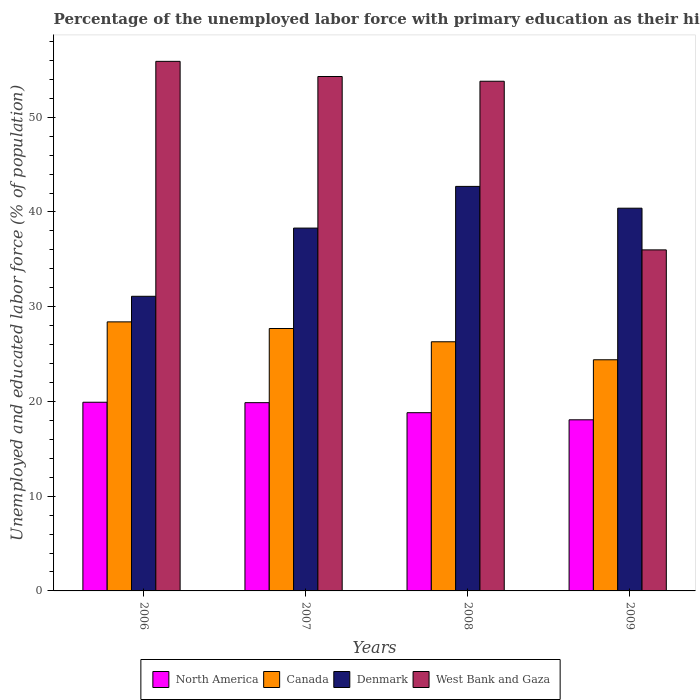In how many cases, is the number of bars for a given year not equal to the number of legend labels?
Your response must be concise. 0. What is the percentage of the unemployed labor force with primary education in North America in 2009?
Your answer should be very brief. 18.06. Across all years, what is the maximum percentage of the unemployed labor force with primary education in Denmark?
Ensure brevity in your answer.  42.7. Across all years, what is the minimum percentage of the unemployed labor force with primary education in Denmark?
Ensure brevity in your answer.  31.1. What is the total percentage of the unemployed labor force with primary education in Canada in the graph?
Give a very brief answer. 106.8. What is the difference between the percentage of the unemployed labor force with primary education in Canada in 2007 and that in 2009?
Make the answer very short. 3.3. What is the difference between the percentage of the unemployed labor force with primary education in West Bank and Gaza in 2008 and the percentage of the unemployed labor force with primary education in Canada in 2007?
Give a very brief answer. 26.1. What is the average percentage of the unemployed labor force with primary education in West Bank and Gaza per year?
Your response must be concise. 50. In the year 2009, what is the difference between the percentage of the unemployed labor force with primary education in West Bank and Gaza and percentage of the unemployed labor force with primary education in North America?
Give a very brief answer. 17.94. What is the ratio of the percentage of the unemployed labor force with primary education in Denmark in 2006 to that in 2007?
Offer a very short reply. 0.81. Is the percentage of the unemployed labor force with primary education in West Bank and Gaza in 2006 less than that in 2007?
Make the answer very short. No. What is the difference between the highest and the second highest percentage of the unemployed labor force with primary education in Canada?
Your response must be concise. 0.7. What is the difference between the highest and the lowest percentage of the unemployed labor force with primary education in North America?
Offer a terse response. 1.85. Is it the case that in every year, the sum of the percentage of the unemployed labor force with primary education in Denmark and percentage of the unemployed labor force with primary education in Canada is greater than the sum of percentage of the unemployed labor force with primary education in North America and percentage of the unemployed labor force with primary education in West Bank and Gaza?
Provide a short and direct response. Yes. What does the 3rd bar from the left in 2007 represents?
Your answer should be compact. Denmark. How many bars are there?
Offer a terse response. 16. Where does the legend appear in the graph?
Provide a succinct answer. Bottom center. How many legend labels are there?
Give a very brief answer. 4. How are the legend labels stacked?
Provide a succinct answer. Horizontal. What is the title of the graph?
Give a very brief answer. Percentage of the unemployed labor force with primary education as their highest grade. What is the label or title of the Y-axis?
Your response must be concise. Unemployed and educated labor force (% of population). What is the Unemployed and educated labor force (% of population) in North America in 2006?
Your response must be concise. 19.92. What is the Unemployed and educated labor force (% of population) in Canada in 2006?
Your answer should be very brief. 28.4. What is the Unemployed and educated labor force (% of population) of Denmark in 2006?
Make the answer very short. 31.1. What is the Unemployed and educated labor force (% of population) of West Bank and Gaza in 2006?
Provide a succinct answer. 55.9. What is the Unemployed and educated labor force (% of population) in North America in 2007?
Your response must be concise. 19.87. What is the Unemployed and educated labor force (% of population) of Canada in 2007?
Offer a terse response. 27.7. What is the Unemployed and educated labor force (% of population) in Denmark in 2007?
Your response must be concise. 38.3. What is the Unemployed and educated labor force (% of population) in West Bank and Gaza in 2007?
Keep it short and to the point. 54.3. What is the Unemployed and educated labor force (% of population) of North America in 2008?
Your answer should be very brief. 18.81. What is the Unemployed and educated labor force (% of population) in Canada in 2008?
Ensure brevity in your answer.  26.3. What is the Unemployed and educated labor force (% of population) in Denmark in 2008?
Make the answer very short. 42.7. What is the Unemployed and educated labor force (% of population) of West Bank and Gaza in 2008?
Your response must be concise. 53.8. What is the Unemployed and educated labor force (% of population) of North America in 2009?
Your answer should be compact. 18.06. What is the Unemployed and educated labor force (% of population) of Canada in 2009?
Your answer should be very brief. 24.4. What is the Unemployed and educated labor force (% of population) in Denmark in 2009?
Your answer should be very brief. 40.4. What is the Unemployed and educated labor force (% of population) of West Bank and Gaza in 2009?
Keep it short and to the point. 36. Across all years, what is the maximum Unemployed and educated labor force (% of population) in North America?
Keep it short and to the point. 19.92. Across all years, what is the maximum Unemployed and educated labor force (% of population) of Canada?
Provide a succinct answer. 28.4. Across all years, what is the maximum Unemployed and educated labor force (% of population) of Denmark?
Your answer should be very brief. 42.7. Across all years, what is the maximum Unemployed and educated labor force (% of population) of West Bank and Gaza?
Keep it short and to the point. 55.9. Across all years, what is the minimum Unemployed and educated labor force (% of population) of North America?
Provide a short and direct response. 18.06. Across all years, what is the minimum Unemployed and educated labor force (% of population) in Canada?
Keep it short and to the point. 24.4. Across all years, what is the minimum Unemployed and educated labor force (% of population) in Denmark?
Offer a terse response. 31.1. Across all years, what is the minimum Unemployed and educated labor force (% of population) in West Bank and Gaza?
Offer a very short reply. 36. What is the total Unemployed and educated labor force (% of population) of North America in the graph?
Offer a terse response. 76.66. What is the total Unemployed and educated labor force (% of population) of Canada in the graph?
Ensure brevity in your answer.  106.8. What is the total Unemployed and educated labor force (% of population) of Denmark in the graph?
Ensure brevity in your answer.  152.5. What is the total Unemployed and educated labor force (% of population) of West Bank and Gaza in the graph?
Keep it short and to the point. 200. What is the difference between the Unemployed and educated labor force (% of population) of North America in 2006 and that in 2007?
Provide a succinct answer. 0.05. What is the difference between the Unemployed and educated labor force (% of population) in Denmark in 2006 and that in 2007?
Ensure brevity in your answer.  -7.2. What is the difference between the Unemployed and educated labor force (% of population) in West Bank and Gaza in 2006 and that in 2007?
Provide a short and direct response. 1.6. What is the difference between the Unemployed and educated labor force (% of population) in North America in 2006 and that in 2008?
Provide a short and direct response. 1.1. What is the difference between the Unemployed and educated labor force (% of population) of Denmark in 2006 and that in 2008?
Give a very brief answer. -11.6. What is the difference between the Unemployed and educated labor force (% of population) of West Bank and Gaza in 2006 and that in 2008?
Your answer should be very brief. 2.1. What is the difference between the Unemployed and educated labor force (% of population) of North America in 2006 and that in 2009?
Your answer should be very brief. 1.85. What is the difference between the Unemployed and educated labor force (% of population) of Denmark in 2006 and that in 2009?
Offer a terse response. -9.3. What is the difference between the Unemployed and educated labor force (% of population) of North America in 2007 and that in 2008?
Provide a short and direct response. 1.06. What is the difference between the Unemployed and educated labor force (% of population) of Denmark in 2007 and that in 2008?
Your answer should be very brief. -4.4. What is the difference between the Unemployed and educated labor force (% of population) in West Bank and Gaza in 2007 and that in 2008?
Provide a succinct answer. 0.5. What is the difference between the Unemployed and educated labor force (% of population) in North America in 2007 and that in 2009?
Your answer should be compact. 1.81. What is the difference between the Unemployed and educated labor force (% of population) of West Bank and Gaza in 2007 and that in 2009?
Your response must be concise. 18.3. What is the difference between the Unemployed and educated labor force (% of population) in North America in 2008 and that in 2009?
Offer a terse response. 0.75. What is the difference between the Unemployed and educated labor force (% of population) of Denmark in 2008 and that in 2009?
Provide a succinct answer. 2.3. What is the difference between the Unemployed and educated labor force (% of population) of West Bank and Gaza in 2008 and that in 2009?
Your answer should be very brief. 17.8. What is the difference between the Unemployed and educated labor force (% of population) in North America in 2006 and the Unemployed and educated labor force (% of population) in Canada in 2007?
Ensure brevity in your answer.  -7.78. What is the difference between the Unemployed and educated labor force (% of population) of North America in 2006 and the Unemployed and educated labor force (% of population) of Denmark in 2007?
Offer a terse response. -18.38. What is the difference between the Unemployed and educated labor force (% of population) of North America in 2006 and the Unemployed and educated labor force (% of population) of West Bank and Gaza in 2007?
Your response must be concise. -34.38. What is the difference between the Unemployed and educated labor force (% of population) in Canada in 2006 and the Unemployed and educated labor force (% of population) in West Bank and Gaza in 2007?
Keep it short and to the point. -25.9. What is the difference between the Unemployed and educated labor force (% of population) in Denmark in 2006 and the Unemployed and educated labor force (% of population) in West Bank and Gaza in 2007?
Keep it short and to the point. -23.2. What is the difference between the Unemployed and educated labor force (% of population) in North America in 2006 and the Unemployed and educated labor force (% of population) in Canada in 2008?
Offer a very short reply. -6.38. What is the difference between the Unemployed and educated labor force (% of population) in North America in 2006 and the Unemployed and educated labor force (% of population) in Denmark in 2008?
Offer a very short reply. -22.78. What is the difference between the Unemployed and educated labor force (% of population) of North America in 2006 and the Unemployed and educated labor force (% of population) of West Bank and Gaza in 2008?
Provide a succinct answer. -33.88. What is the difference between the Unemployed and educated labor force (% of population) of Canada in 2006 and the Unemployed and educated labor force (% of population) of Denmark in 2008?
Make the answer very short. -14.3. What is the difference between the Unemployed and educated labor force (% of population) in Canada in 2006 and the Unemployed and educated labor force (% of population) in West Bank and Gaza in 2008?
Give a very brief answer. -25.4. What is the difference between the Unemployed and educated labor force (% of population) in Denmark in 2006 and the Unemployed and educated labor force (% of population) in West Bank and Gaza in 2008?
Offer a very short reply. -22.7. What is the difference between the Unemployed and educated labor force (% of population) in North America in 2006 and the Unemployed and educated labor force (% of population) in Canada in 2009?
Provide a short and direct response. -4.48. What is the difference between the Unemployed and educated labor force (% of population) of North America in 2006 and the Unemployed and educated labor force (% of population) of Denmark in 2009?
Ensure brevity in your answer.  -20.48. What is the difference between the Unemployed and educated labor force (% of population) of North America in 2006 and the Unemployed and educated labor force (% of population) of West Bank and Gaza in 2009?
Give a very brief answer. -16.08. What is the difference between the Unemployed and educated labor force (% of population) of Canada in 2006 and the Unemployed and educated labor force (% of population) of Denmark in 2009?
Ensure brevity in your answer.  -12. What is the difference between the Unemployed and educated labor force (% of population) in North America in 2007 and the Unemployed and educated labor force (% of population) in Canada in 2008?
Give a very brief answer. -6.43. What is the difference between the Unemployed and educated labor force (% of population) of North America in 2007 and the Unemployed and educated labor force (% of population) of Denmark in 2008?
Make the answer very short. -22.83. What is the difference between the Unemployed and educated labor force (% of population) of North America in 2007 and the Unemployed and educated labor force (% of population) of West Bank and Gaza in 2008?
Your answer should be very brief. -33.93. What is the difference between the Unemployed and educated labor force (% of population) of Canada in 2007 and the Unemployed and educated labor force (% of population) of Denmark in 2008?
Make the answer very short. -15. What is the difference between the Unemployed and educated labor force (% of population) in Canada in 2007 and the Unemployed and educated labor force (% of population) in West Bank and Gaza in 2008?
Give a very brief answer. -26.1. What is the difference between the Unemployed and educated labor force (% of population) in Denmark in 2007 and the Unemployed and educated labor force (% of population) in West Bank and Gaza in 2008?
Your response must be concise. -15.5. What is the difference between the Unemployed and educated labor force (% of population) in North America in 2007 and the Unemployed and educated labor force (% of population) in Canada in 2009?
Offer a terse response. -4.53. What is the difference between the Unemployed and educated labor force (% of population) in North America in 2007 and the Unemployed and educated labor force (% of population) in Denmark in 2009?
Offer a terse response. -20.53. What is the difference between the Unemployed and educated labor force (% of population) of North America in 2007 and the Unemployed and educated labor force (% of population) of West Bank and Gaza in 2009?
Make the answer very short. -16.13. What is the difference between the Unemployed and educated labor force (% of population) in Canada in 2007 and the Unemployed and educated labor force (% of population) in Denmark in 2009?
Ensure brevity in your answer.  -12.7. What is the difference between the Unemployed and educated labor force (% of population) of Canada in 2007 and the Unemployed and educated labor force (% of population) of West Bank and Gaza in 2009?
Give a very brief answer. -8.3. What is the difference between the Unemployed and educated labor force (% of population) in Denmark in 2007 and the Unemployed and educated labor force (% of population) in West Bank and Gaza in 2009?
Ensure brevity in your answer.  2.3. What is the difference between the Unemployed and educated labor force (% of population) of North America in 2008 and the Unemployed and educated labor force (% of population) of Canada in 2009?
Your answer should be very brief. -5.59. What is the difference between the Unemployed and educated labor force (% of population) in North America in 2008 and the Unemployed and educated labor force (% of population) in Denmark in 2009?
Your response must be concise. -21.59. What is the difference between the Unemployed and educated labor force (% of population) of North America in 2008 and the Unemployed and educated labor force (% of population) of West Bank and Gaza in 2009?
Your response must be concise. -17.19. What is the difference between the Unemployed and educated labor force (% of population) of Canada in 2008 and the Unemployed and educated labor force (% of population) of Denmark in 2009?
Provide a short and direct response. -14.1. What is the difference between the Unemployed and educated labor force (% of population) of Denmark in 2008 and the Unemployed and educated labor force (% of population) of West Bank and Gaza in 2009?
Your answer should be very brief. 6.7. What is the average Unemployed and educated labor force (% of population) in North America per year?
Your answer should be compact. 19.17. What is the average Unemployed and educated labor force (% of population) of Canada per year?
Your answer should be very brief. 26.7. What is the average Unemployed and educated labor force (% of population) in Denmark per year?
Provide a short and direct response. 38.12. What is the average Unemployed and educated labor force (% of population) in West Bank and Gaza per year?
Offer a very short reply. 50. In the year 2006, what is the difference between the Unemployed and educated labor force (% of population) of North America and Unemployed and educated labor force (% of population) of Canada?
Offer a terse response. -8.48. In the year 2006, what is the difference between the Unemployed and educated labor force (% of population) of North America and Unemployed and educated labor force (% of population) of Denmark?
Your answer should be compact. -11.18. In the year 2006, what is the difference between the Unemployed and educated labor force (% of population) in North America and Unemployed and educated labor force (% of population) in West Bank and Gaza?
Offer a very short reply. -35.98. In the year 2006, what is the difference between the Unemployed and educated labor force (% of population) of Canada and Unemployed and educated labor force (% of population) of West Bank and Gaza?
Provide a short and direct response. -27.5. In the year 2006, what is the difference between the Unemployed and educated labor force (% of population) of Denmark and Unemployed and educated labor force (% of population) of West Bank and Gaza?
Keep it short and to the point. -24.8. In the year 2007, what is the difference between the Unemployed and educated labor force (% of population) of North America and Unemployed and educated labor force (% of population) of Canada?
Your answer should be very brief. -7.83. In the year 2007, what is the difference between the Unemployed and educated labor force (% of population) in North America and Unemployed and educated labor force (% of population) in Denmark?
Offer a terse response. -18.43. In the year 2007, what is the difference between the Unemployed and educated labor force (% of population) of North America and Unemployed and educated labor force (% of population) of West Bank and Gaza?
Offer a very short reply. -34.43. In the year 2007, what is the difference between the Unemployed and educated labor force (% of population) in Canada and Unemployed and educated labor force (% of population) in Denmark?
Keep it short and to the point. -10.6. In the year 2007, what is the difference between the Unemployed and educated labor force (% of population) of Canada and Unemployed and educated labor force (% of population) of West Bank and Gaza?
Ensure brevity in your answer.  -26.6. In the year 2008, what is the difference between the Unemployed and educated labor force (% of population) in North America and Unemployed and educated labor force (% of population) in Canada?
Keep it short and to the point. -7.49. In the year 2008, what is the difference between the Unemployed and educated labor force (% of population) of North America and Unemployed and educated labor force (% of population) of Denmark?
Make the answer very short. -23.89. In the year 2008, what is the difference between the Unemployed and educated labor force (% of population) of North America and Unemployed and educated labor force (% of population) of West Bank and Gaza?
Your response must be concise. -34.99. In the year 2008, what is the difference between the Unemployed and educated labor force (% of population) in Canada and Unemployed and educated labor force (% of population) in Denmark?
Provide a short and direct response. -16.4. In the year 2008, what is the difference between the Unemployed and educated labor force (% of population) of Canada and Unemployed and educated labor force (% of population) of West Bank and Gaza?
Offer a terse response. -27.5. In the year 2009, what is the difference between the Unemployed and educated labor force (% of population) in North America and Unemployed and educated labor force (% of population) in Canada?
Keep it short and to the point. -6.34. In the year 2009, what is the difference between the Unemployed and educated labor force (% of population) in North America and Unemployed and educated labor force (% of population) in Denmark?
Offer a terse response. -22.34. In the year 2009, what is the difference between the Unemployed and educated labor force (% of population) of North America and Unemployed and educated labor force (% of population) of West Bank and Gaza?
Your answer should be very brief. -17.94. In the year 2009, what is the difference between the Unemployed and educated labor force (% of population) in Canada and Unemployed and educated labor force (% of population) in Denmark?
Ensure brevity in your answer.  -16. In the year 2009, what is the difference between the Unemployed and educated labor force (% of population) in Canada and Unemployed and educated labor force (% of population) in West Bank and Gaza?
Keep it short and to the point. -11.6. In the year 2009, what is the difference between the Unemployed and educated labor force (% of population) of Denmark and Unemployed and educated labor force (% of population) of West Bank and Gaza?
Give a very brief answer. 4.4. What is the ratio of the Unemployed and educated labor force (% of population) in North America in 2006 to that in 2007?
Make the answer very short. 1. What is the ratio of the Unemployed and educated labor force (% of population) of Canada in 2006 to that in 2007?
Offer a terse response. 1.03. What is the ratio of the Unemployed and educated labor force (% of population) of Denmark in 2006 to that in 2007?
Ensure brevity in your answer.  0.81. What is the ratio of the Unemployed and educated labor force (% of population) in West Bank and Gaza in 2006 to that in 2007?
Give a very brief answer. 1.03. What is the ratio of the Unemployed and educated labor force (% of population) of North America in 2006 to that in 2008?
Your answer should be compact. 1.06. What is the ratio of the Unemployed and educated labor force (% of population) of Canada in 2006 to that in 2008?
Give a very brief answer. 1.08. What is the ratio of the Unemployed and educated labor force (% of population) in Denmark in 2006 to that in 2008?
Offer a very short reply. 0.73. What is the ratio of the Unemployed and educated labor force (% of population) of West Bank and Gaza in 2006 to that in 2008?
Offer a very short reply. 1.04. What is the ratio of the Unemployed and educated labor force (% of population) of North America in 2006 to that in 2009?
Your response must be concise. 1.1. What is the ratio of the Unemployed and educated labor force (% of population) of Canada in 2006 to that in 2009?
Give a very brief answer. 1.16. What is the ratio of the Unemployed and educated labor force (% of population) of Denmark in 2006 to that in 2009?
Ensure brevity in your answer.  0.77. What is the ratio of the Unemployed and educated labor force (% of population) of West Bank and Gaza in 2006 to that in 2009?
Make the answer very short. 1.55. What is the ratio of the Unemployed and educated labor force (% of population) in North America in 2007 to that in 2008?
Ensure brevity in your answer.  1.06. What is the ratio of the Unemployed and educated labor force (% of population) in Canada in 2007 to that in 2008?
Give a very brief answer. 1.05. What is the ratio of the Unemployed and educated labor force (% of population) of Denmark in 2007 to that in 2008?
Your answer should be very brief. 0.9. What is the ratio of the Unemployed and educated labor force (% of population) of West Bank and Gaza in 2007 to that in 2008?
Give a very brief answer. 1.01. What is the ratio of the Unemployed and educated labor force (% of population) of North America in 2007 to that in 2009?
Your response must be concise. 1.1. What is the ratio of the Unemployed and educated labor force (% of population) of Canada in 2007 to that in 2009?
Provide a succinct answer. 1.14. What is the ratio of the Unemployed and educated labor force (% of population) of Denmark in 2007 to that in 2009?
Provide a short and direct response. 0.95. What is the ratio of the Unemployed and educated labor force (% of population) of West Bank and Gaza in 2007 to that in 2009?
Offer a terse response. 1.51. What is the ratio of the Unemployed and educated labor force (% of population) of North America in 2008 to that in 2009?
Give a very brief answer. 1.04. What is the ratio of the Unemployed and educated labor force (% of population) in Canada in 2008 to that in 2009?
Keep it short and to the point. 1.08. What is the ratio of the Unemployed and educated labor force (% of population) in Denmark in 2008 to that in 2009?
Your answer should be compact. 1.06. What is the ratio of the Unemployed and educated labor force (% of population) of West Bank and Gaza in 2008 to that in 2009?
Your response must be concise. 1.49. What is the difference between the highest and the second highest Unemployed and educated labor force (% of population) in North America?
Provide a short and direct response. 0.05. What is the difference between the highest and the second highest Unemployed and educated labor force (% of population) of Denmark?
Ensure brevity in your answer.  2.3. What is the difference between the highest and the lowest Unemployed and educated labor force (% of population) in North America?
Provide a short and direct response. 1.85. 